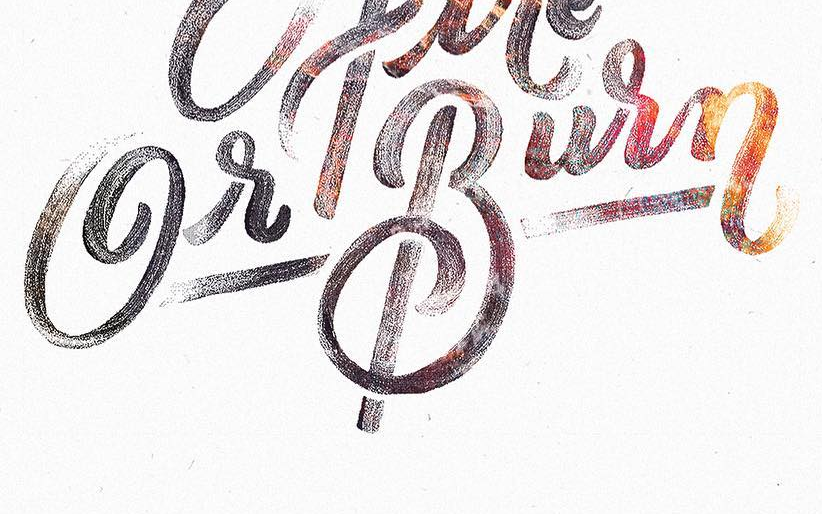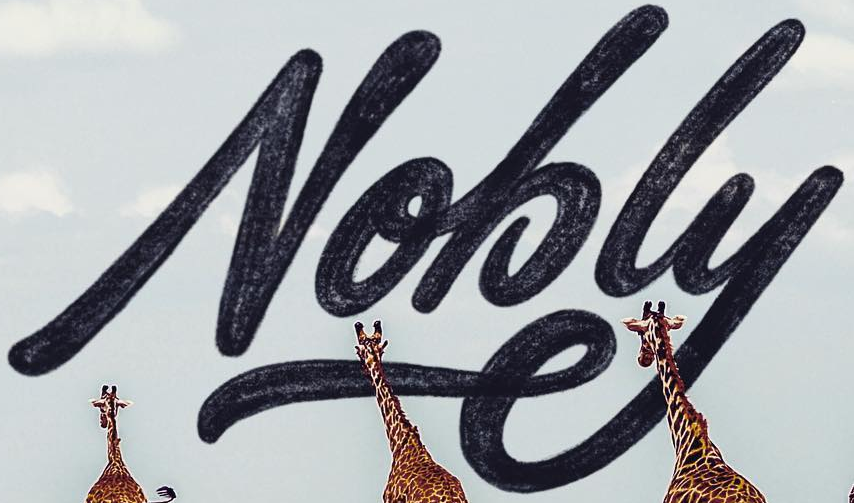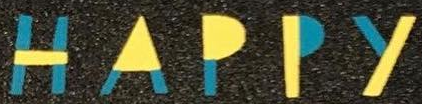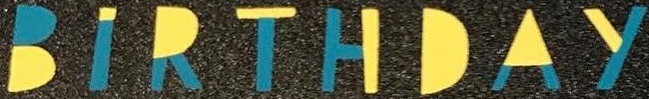What words are shown in these images in order, separated by a semicolon? GrBurn; Nobly; HAPPY; BIRTHDAY 